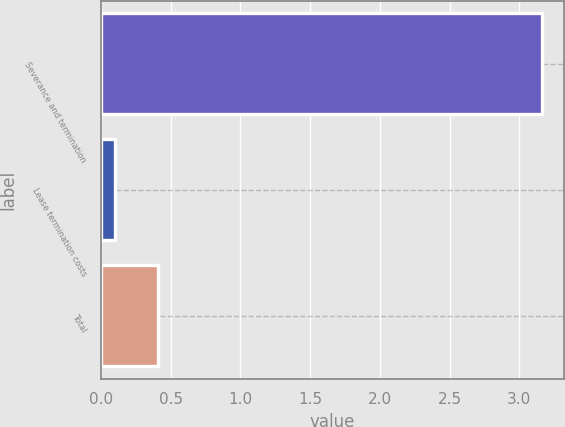Convert chart to OTSL. <chart><loc_0><loc_0><loc_500><loc_500><bar_chart><fcel>Severance and termination<fcel>Lease termination costs<fcel>Total<nl><fcel>3.16<fcel>0.1<fcel>0.41<nl></chart> 